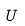<formula> <loc_0><loc_0><loc_500><loc_500>U</formula> 